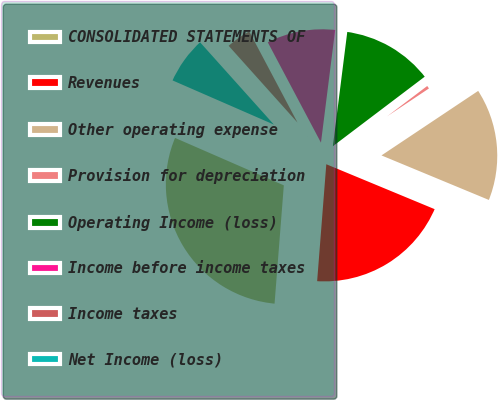Convert chart to OTSL. <chart><loc_0><loc_0><loc_500><loc_500><pie_chart><fcel>CONSOLIDATED STATEMENTS OF<fcel>Revenues<fcel>Other operating expense<fcel>Provision for depreciation<fcel>Operating Income (loss)<fcel>Income before income taxes<fcel>Income taxes<fcel>Net Income (loss)<nl><fcel>30.3%<fcel>19.99%<fcel>15.62%<fcel>0.95%<fcel>12.69%<fcel>9.75%<fcel>3.88%<fcel>6.82%<nl></chart> 